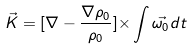<formula> <loc_0><loc_0><loc_500><loc_500>\vec { K } = [ { \nabla } - \frac { { \nabla } { \rho } _ { 0 } } { { \rho } _ { 0 } } ] { \times } \int { \vec { { \omega } _ { 0 } } d t }</formula> 